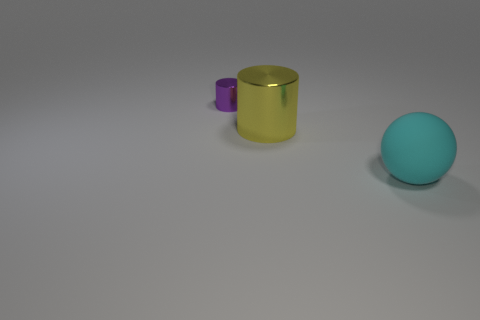Is there anything else that is the same size as the yellow metallic thing?
Ensure brevity in your answer.  Yes. What is the material of the object that is in front of the cylinder right of the small object?
Provide a short and direct response. Rubber. How many shiny objects are either purple objects or balls?
Offer a very short reply. 1. What color is the big object that is the same shape as the small purple thing?
Make the answer very short. Yellow. How many big matte things have the same color as the big metal thing?
Provide a short and direct response. 0. There is a big thing that is behind the cyan matte sphere; is there a yellow metallic cylinder that is in front of it?
Your answer should be very brief. No. What number of objects are both left of the cyan matte sphere and right of the small object?
Offer a very short reply. 1. What number of other purple cylinders are the same material as the small cylinder?
Offer a very short reply. 0. What is the size of the shiny thing to the right of the cylinder that is behind the big metal object?
Give a very brief answer. Large. Is there a cyan object that has the same shape as the tiny purple thing?
Make the answer very short. No. 